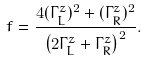Convert formula to latex. <formula><loc_0><loc_0><loc_500><loc_500>f = \frac { 4 ( \Gamma _ { L } ^ { z } ) ^ { 2 } + ( \Gamma _ { R } ^ { z } ) ^ { 2 } } { \left ( 2 \Gamma _ { L } ^ { z } + \Gamma _ { R } ^ { z } \right ) ^ { 2 } } .</formula> 